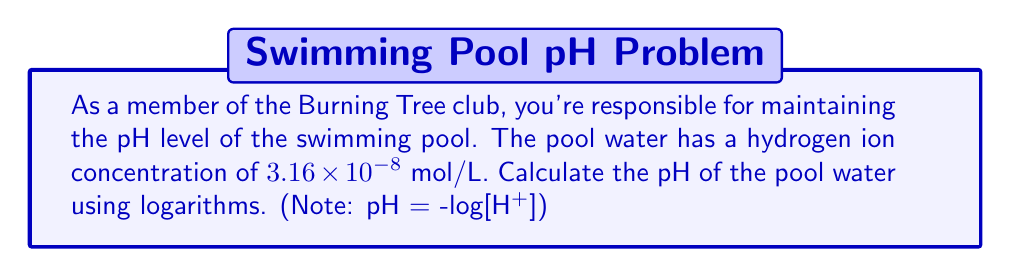Can you answer this question? To solve this problem, we need to use the formula for pH and the given hydrogen ion concentration. Let's break it down step-by-step:

1) The formula for pH is:
   $$ \text{pH} = -\log_{10}[\text{H}^+] $$
   where $[\text{H}^+]$ is the concentration of hydrogen ions in mol/L.

2) We're given that $[\text{H}^+] = 3.16 \times 10^{-8}$ mol/L.

3) Let's substitute this into our pH formula:
   $$ \text{pH} = -\log_{10}(3.16 \times 10^{-8}) $$

4) To solve this, we can use the properties of logarithms. Specifically:
   $$ \log(a \times 10^n) = \log(a) + n $$

5) Applying this to our problem:
   $$ \text{pH} = -(\log_{10}(3.16) + \log_{10}(10^{-8})) $$

6) We know that $\log_{10}(10^{-8}) = -8$, so:
   $$ \text{pH} = -(\log_{10}(3.16) - 8) $$

7) Using a calculator, we find that $\log_{10}(3.16) \approx 0.4997$

8) Now we can calculate:
   $$ \text{pH} = -(0.4997 - 8) = -0.4997 + 8 = 7.5003 $$

9) Rounding to two decimal places, as is common for pH values:
   $$ \text{pH} \approx 7.50 $$
Answer: The pH of the pool water is approximately 7.50. 